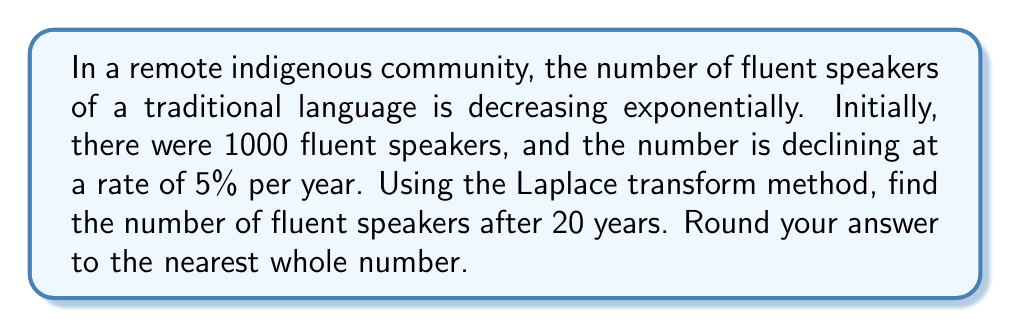Can you solve this math problem? Let's approach this problem step by step using the Laplace transform method:

1) Let $N(t)$ be the number of fluent speakers at time $t$ (in years). We're given that $N(0) = 1000$ and the decay rate is 5% per year.

2) The differential equation modeling exponential decay is:

   $$\frac{dN}{dt} = -0.05N$$

3) Taking the Laplace transform of both sides:

   $$\mathcal{L}\left\{\frac{dN}{dt}\right\} = \mathcal{L}\{-0.05N\}$$

4) Using the Laplace transform properties:

   $$s\mathcal{L}\{N\} - N(0) = -0.05\mathcal{L}\{N\}$$

5) Let $\mathcal{L}\{N\} = F(s)$. Substituting and rearranging:

   $$sF(s) - 1000 = -0.05F(s)$$
   $$(s + 0.05)F(s) = 1000$$
   $$F(s) = \frac{1000}{s + 0.05}$$

6) The inverse Laplace transform of $\frac{1}{s + a}$ is $e^{-at}$. Therefore:

   $$N(t) = 1000e^{-0.05t}$$

7) To find the number of speakers after 20 years, we evaluate $N(20)$:

   $$N(20) = 1000e^{-0.05(20)} = 1000e^{-1} \approx 367.88$$

8) Rounding to the nearest whole number:

   $$N(20) \approx 368$$
Answer: 368 fluent speakers 